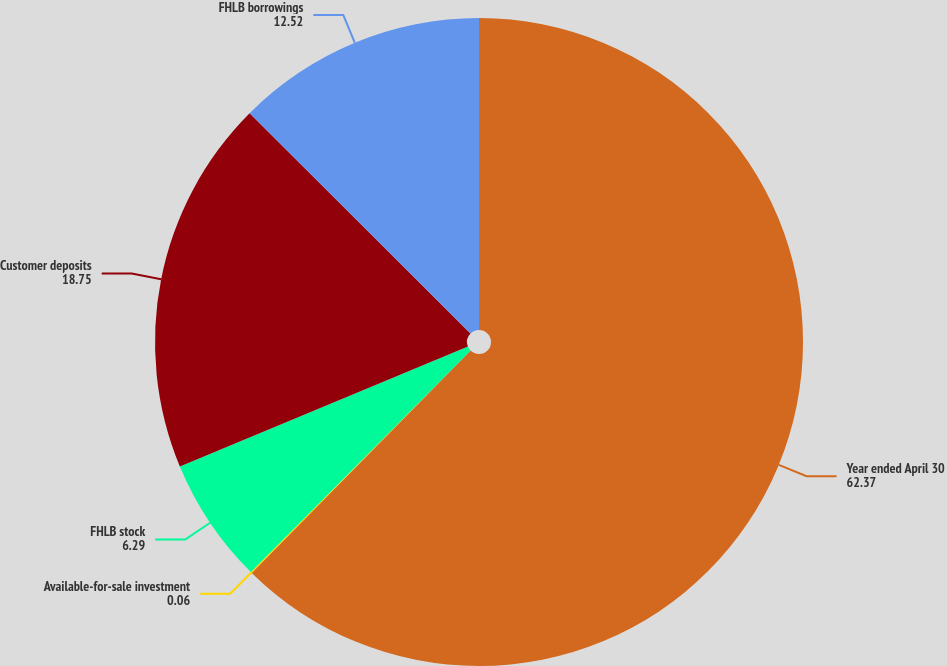Convert chart. <chart><loc_0><loc_0><loc_500><loc_500><pie_chart><fcel>Year ended April 30<fcel>Available-for-sale investment<fcel>FHLB stock<fcel>Customer deposits<fcel>FHLB borrowings<nl><fcel>62.37%<fcel>0.06%<fcel>6.29%<fcel>18.75%<fcel>12.52%<nl></chart> 